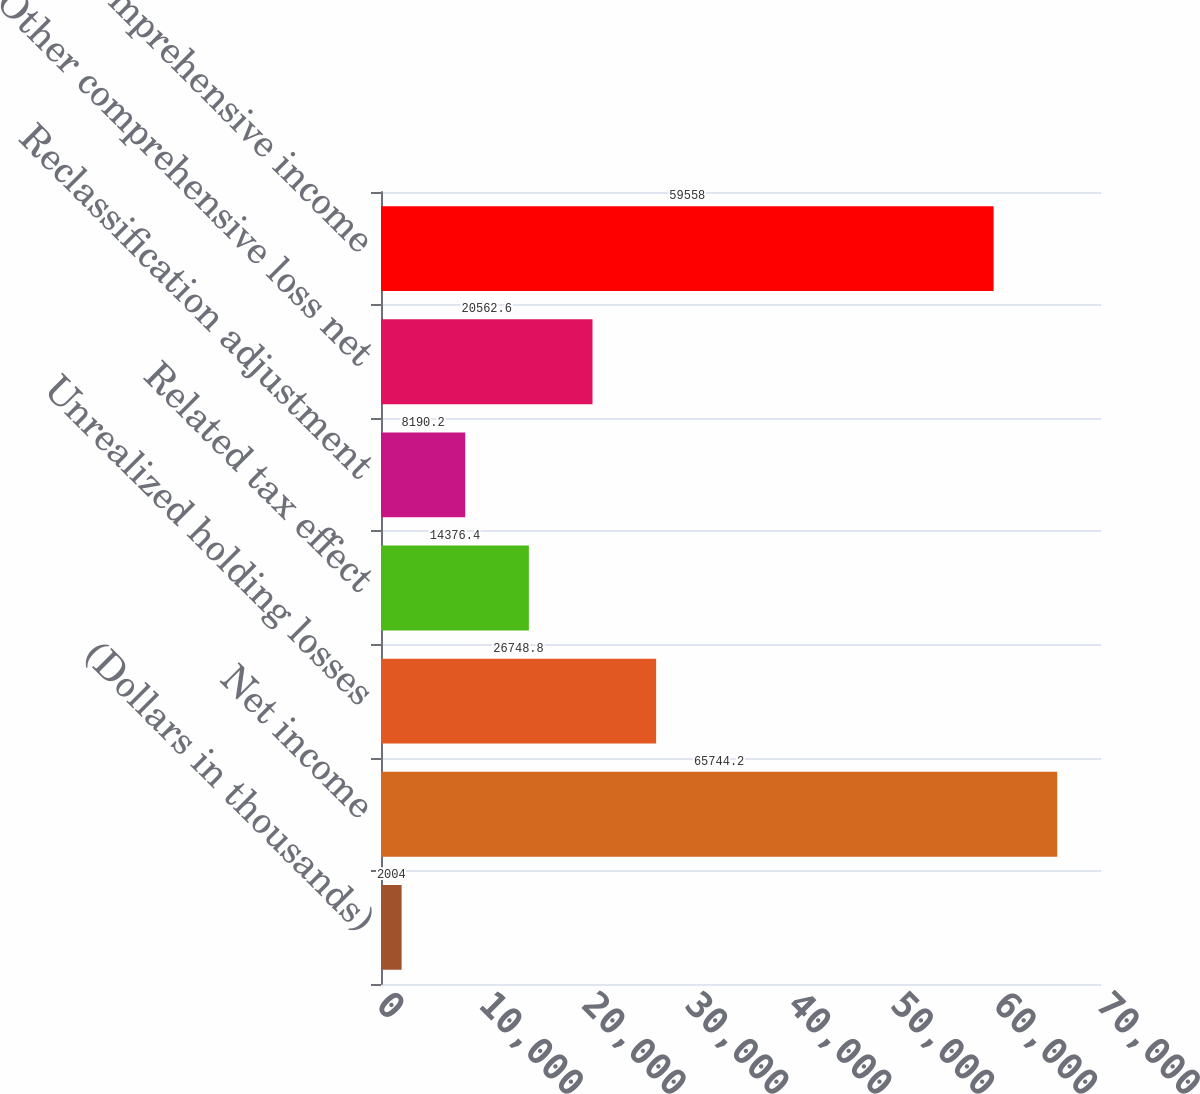Convert chart. <chart><loc_0><loc_0><loc_500><loc_500><bar_chart><fcel>(Dollars in thousands)<fcel>Net income<fcel>Unrealized holding losses<fcel>Related tax effect<fcel>Reclassification adjustment<fcel>Other comprehensive loss net<fcel>Comprehensive income<nl><fcel>2004<fcel>65744.2<fcel>26748.8<fcel>14376.4<fcel>8190.2<fcel>20562.6<fcel>59558<nl></chart> 